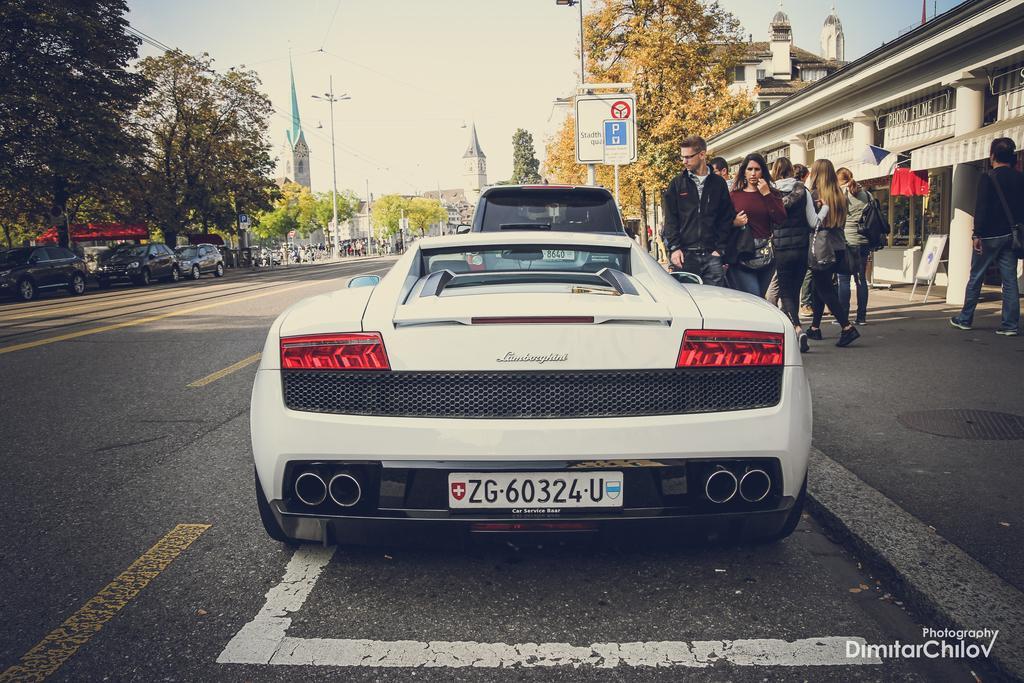How would you summarize this image in a sentence or two? In this picture there are vehicles on the road and there are group of people walking on the road and there are trees and poles and there are buildings and there are boards on the poles. At the top there is sky. At the bottom there is a road. At the bottom right there is text and there is a flag on the building. 